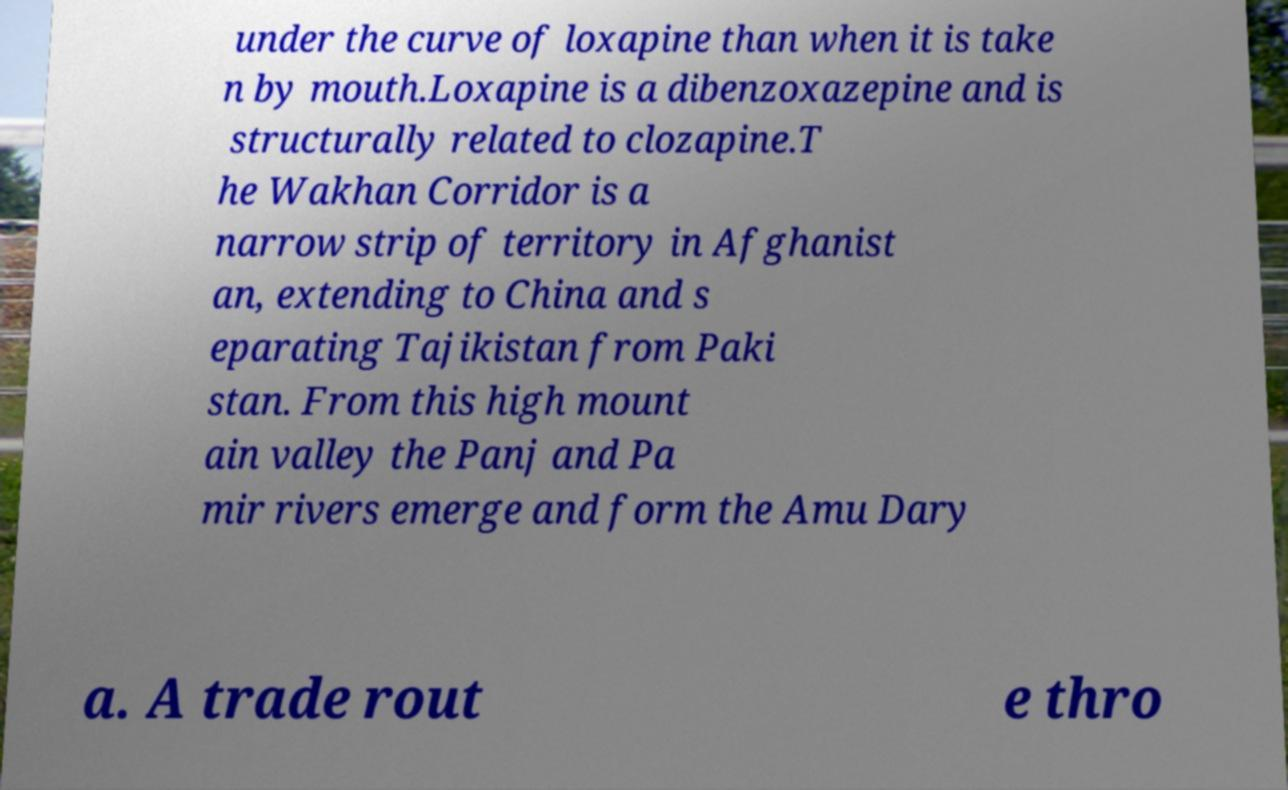Please read and relay the text visible in this image. What does it say? under the curve of loxapine than when it is take n by mouth.Loxapine is a dibenzoxazepine and is structurally related to clozapine.T he Wakhan Corridor is a narrow strip of territory in Afghanist an, extending to China and s eparating Tajikistan from Paki stan. From this high mount ain valley the Panj and Pa mir rivers emerge and form the Amu Dary a. A trade rout e thro 